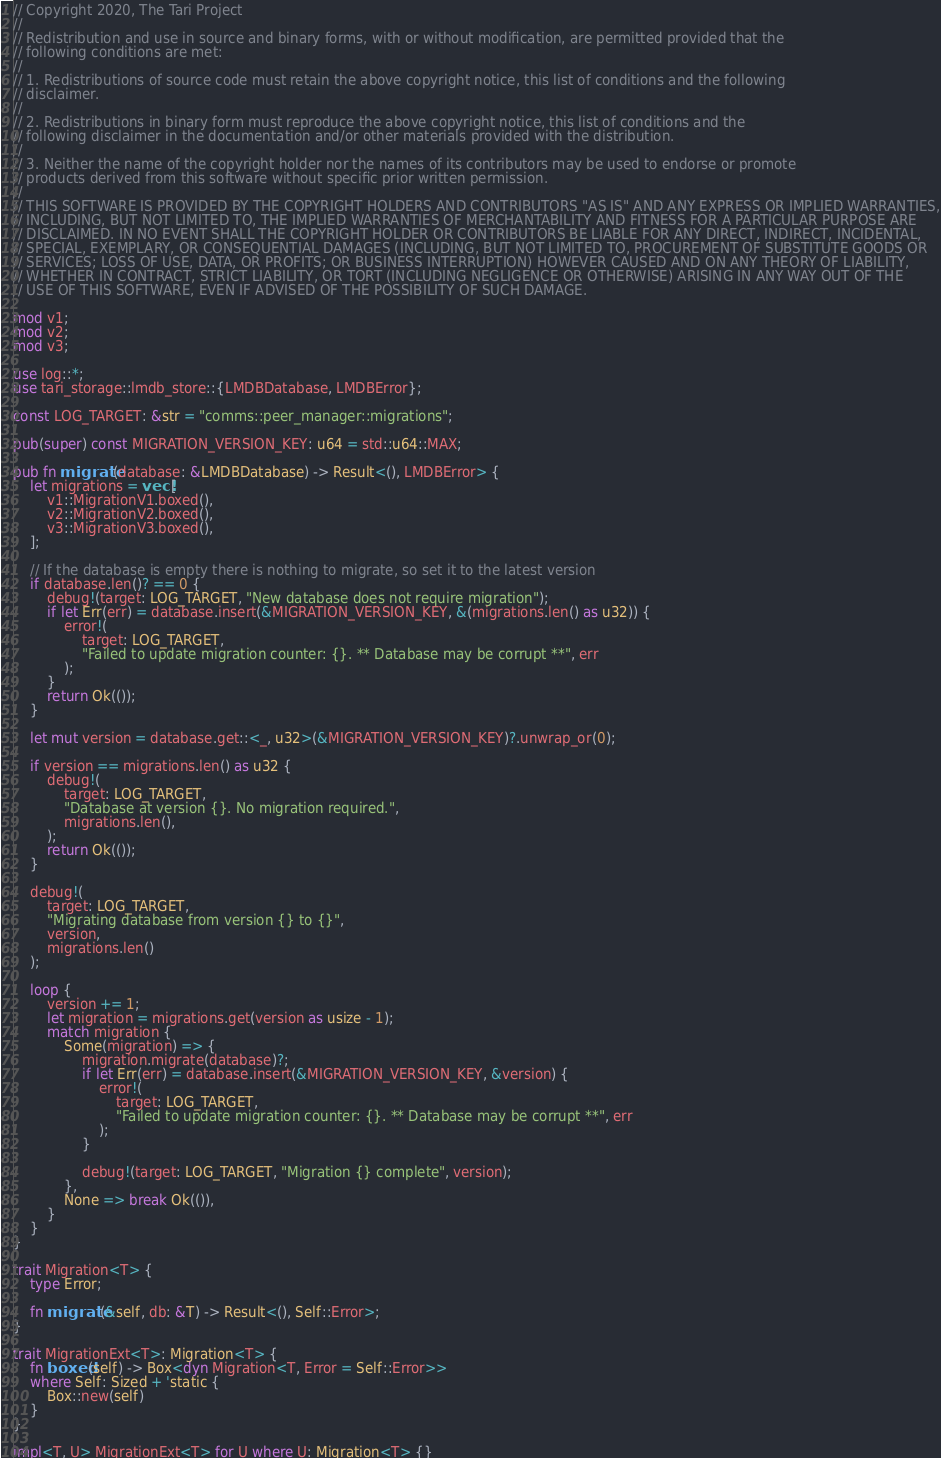Convert code to text. <code><loc_0><loc_0><loc_500><loc_500><_Rust_>// Copyright 2020, The Tari Project
//
// Redistribution and use in source and binary forms, with or without modification, are permitted provided that the
// following conditions are met:
//
// 1. Redistributions of source code must retain the above copyright notice, this list of conditions and the following
// disclaimer.
//
// 2. Redistributions in binary form must reproduce the above copyright notice, this list of conditions and the
// following disclaimer in the documentation and/or other materials provided with the distribution.
//
// 3. Neither the name of the copyright holder nor the names of its contributors may be used to endorse or promote
// products derived from this software without specific prior written permission.
//
// THIS SOFTWARE IS PROVIDED BY THE COPYRIGHT HOLDERS AND CONTRIBUTORS "AS IS" AND ANY EXPRESS OR IMPLIED WARRANTIES,
// INCLUDING, BUT NOT LIMITED TO, THE IMPLIED WARRANTIES OF MERCHANTABILITY AND FITNESS FOR A PARTICULAR PURPOSE ARE
// DISCLAIMED. IN NO EVENT SHALL THE COPYRIGHT HOLDER OR CONTRIBUTORS BE LIABLE FOR ANY DIRECT, INDIRECT, INCIDENTAL,
// SPECIAL, EXEMPLARY, OR CONSEQUENTIAL DAMAGES (INCLUDING, BUT NOT LIMITED TO, PROCUREMENT OF SUBSTITUTE GOODS OR
// SERVICES; LOSS OF USE, DATA, OR PROFITS; OR BUSINESS INTERRUPTION) HOWEVER CAUSED AND ON ANY THEORY OF LIABILITY,
// WHETHER IN CONTRACT, STRICT LIABILITY, OR TORT (INCLUDING NEGLIGENCE OR OTHERWISE) ARISING IN ANY WAY OUT OF THE
// USE OF THIS SOFTWARE, EVEN IF ADVISED OF THE POSSIBILITY OF SUCH DAMAGE.

mod v1;
mod v2;
mod v3;

use log::*;
use tari_storage::lmdb_store::{LMDBDatabase, LMDBError};

const LOG_TARGET: &str = "comms::peer_manager::migrations";

pub(super) const MIGRATION_VERSION_KEY: u64 = std::u64::MAX;

pub fn migrate(database: &LMDBDatabase) -> Result<(), LMDBError> {
    let migrations = vec![
        v1::MigrationV1.boxed(),
        v2::MigrationV2.boxed(),
        v3::MigrationV3.boxed(),
    ];

    // If the database is empty there is nothing to migrate, so set it to the latest version
    if database.len()? == 0 {
        debug!(target: LOG_TARGET, "New database does not require migration");
        if let Err(err) = database.insert(&MIGRATION_VERSION_KEY, &(migrations.len() as u32)) {
            error!(
                target: LOG_TARGET,
                "Failed to update migration counter: {}. ** Database may be corrupt **", err
            );
        }
        return Ok(());
    }

    let mut version = database.get::<_, u32>(&MIGRATION_VERSION_KEY)?.unwrap_or(0);

    if version == migrations.len() as u32 {
        debug!(
            target: LOG_TARGET,
            "Database at version {}. No migration required.",
            migrations.len(),
        );
        return Ok(());
    }

    debug!(
        target: LOG_TARGET,
        "Migrating database from version {} to {}",
        version,
        migrations.len()
    );

    loop {
        version += 1;
        let migration = migrations.get(version as usize - 1);
        match migration {
            Some(migration) => {
                migration.migrate(database)?;
                if let Err(err) = database.insert(&MIGRATION_VERSION_KEY, &version) {
                    error!(
                        target: LOG_TARGET,
                        "Failed to update migration counter: {}. ** Database may be corrupt **", err
                    );
                }

                debug!(target: LOG_TARGET, "Migration {} complete", version);
            },
            None => break Ok(()),
        }
    }
}

trait Migration<T> {
    type Error;

    fn migrate(&self, db: &T) -> Result<(), Self::Error>;
}

trait MigrationExt<T>: Migration<T> {
    fn boxed(self) -> Box<dyn Migration<T, Error = Self::Error>>
    where Self: Sized + 'static {
        Box::new(self)
    }
}

impl<T, U> MigrationExt<T> for U where U: Migration<T> {}
</code> 